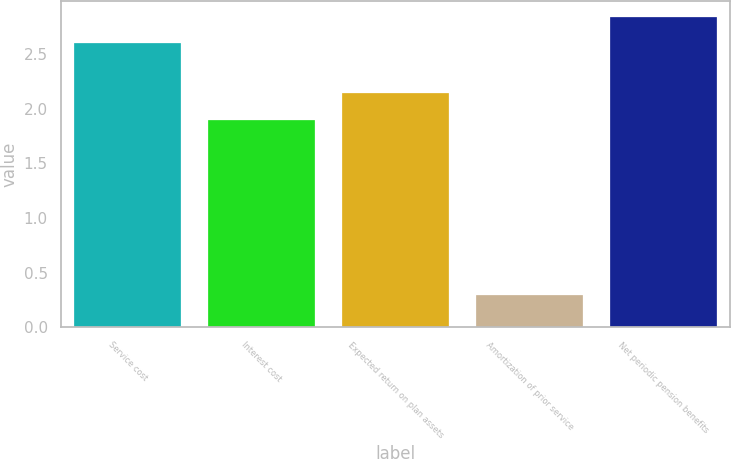Convert chart. <chart><loc_0><loc_0><loc_500><loc_500><bar_chart><fcel>Service cost<fcel>Interest cost<fcel>Expected return on plan assets<fcel>Amortization of prior service<fcel>Net periodic pension benefits<nl><fcel>2.6<fcel>1.9<fcel>2.14<fcel>0.3<fcel>2.84<nl></chart> 